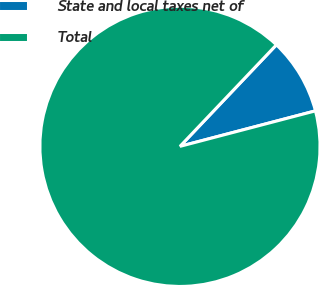Convert chart. <chart><loc_0><loc_0><loc_500><loc_500><pie_chart><fcel>State and local taxes net of<fcel>Total<nl><fcel>8.83%<fcel>91.17%<nl></chart> 